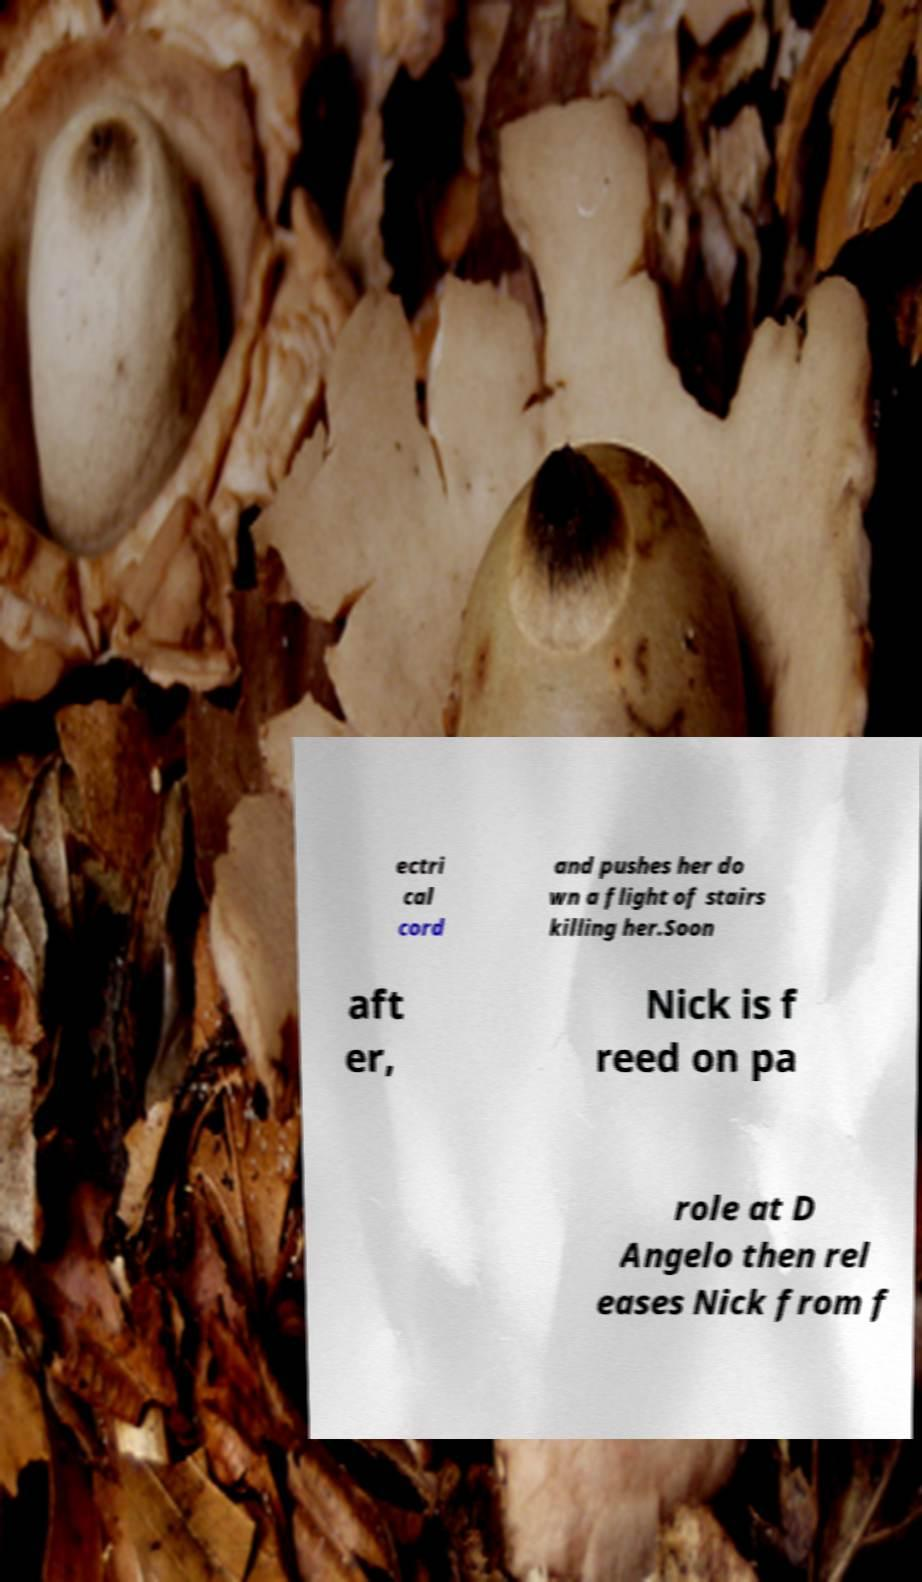I need the written content from this picture converted into text. Can you do that? ectri cal cord and pushes her do wn a flight of stairs killing her.Soon aft er, Nick is f reed on pa role at D Angelo then rel eases Nick from f 